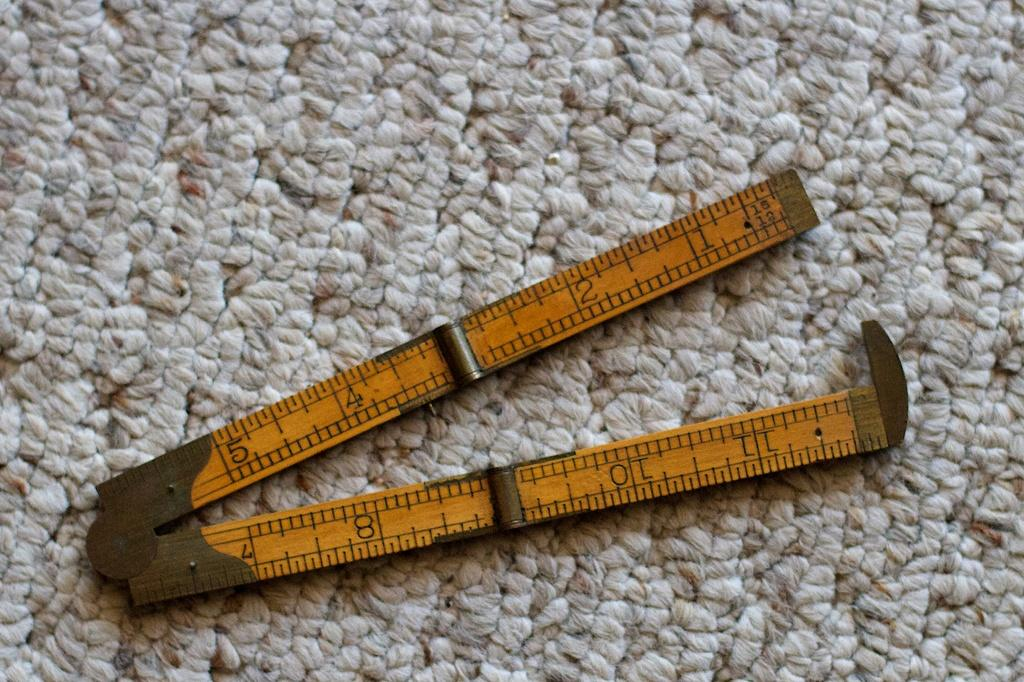<image>
Provide a brief description of the given image. On white and beige carpet a pocket sized ruler, measuring 12 inches, can be seen folded almost in half. 